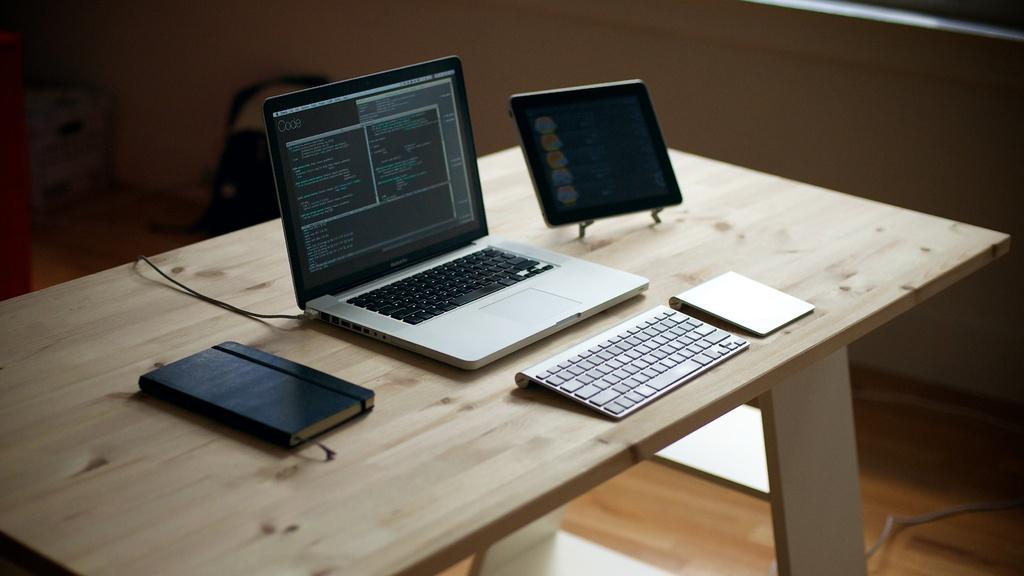What piece of furniture is visible in the image? There is a table in the image. What electronic devices are placed on the table? A laptop, a keyboard, and an iPad are placed on the table. What type of writing material is present on the table? A diary is placed on the table. What can be seen in the background of the image? There is a wall in the background of the image. What type of feast is being prepared on the table in the image? There is no feast being prepared on the table in the image; it contains electronic devices and a diary. What type of metal is the copper wire used in the image? There is no copper wire present in the image. 